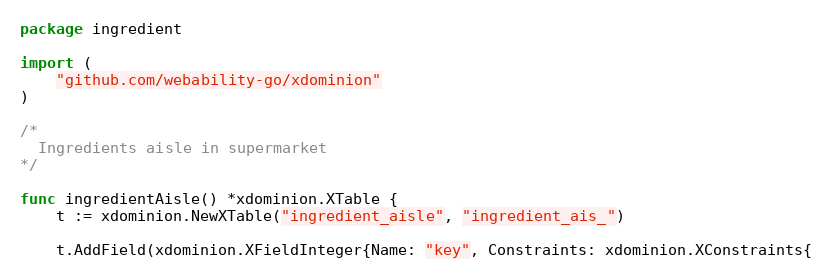Convert code to text. <code><loc_0><loc_0><loc_500><loc_500><_Go_>package ingredient

import (
	"github.com/webability-go/xdominion"
)

/*
  Ingredients aisle in supermarket
*/

func ingredientAisle() *xdominion.XTable {
	t := xdominion.NewXTable("ingredient_aisle", "ingredient_ais_")

	t.AddField(xdominion.XFieldInteger{Name: "key", Constraints: xdominion.XConstraints{</code> 